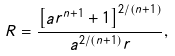<formula> <loc_0><loc_0><loc_500><loc_500>R = \frac { \left [ a r ^ { n + 1 } + 1 \right ] ^ { 2 / ( n + 1 ) } } { a ^ { 2 / ( n + 1 ) } r } ,</formula> 